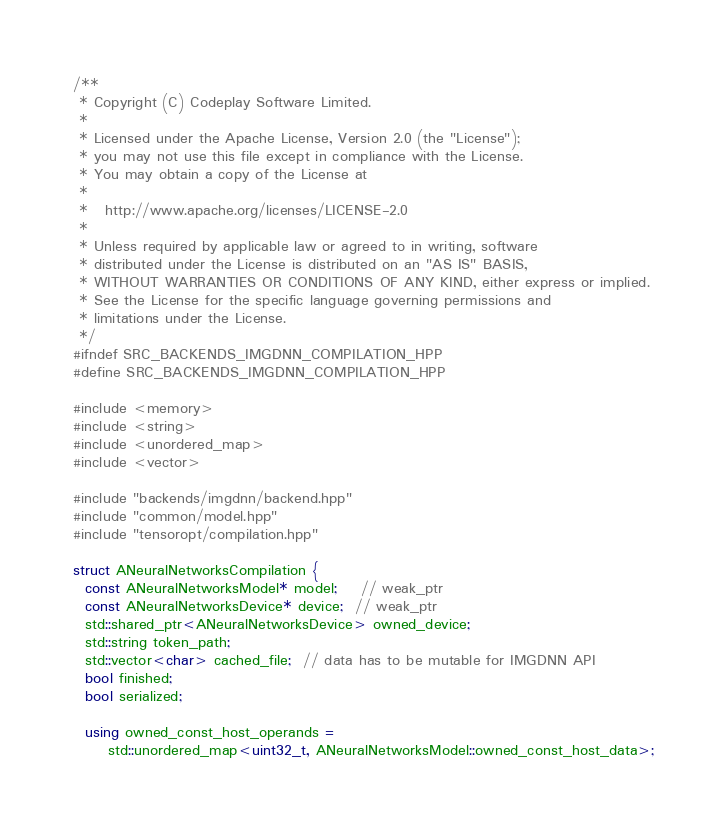<code> <loc_0><loc_0><loc_500><loc_500><_C++_>/**
 * Copyright (C) Codeplay Software Limited.
 *
 * Licensed under the Apache License, Version 2.0 (the "License");
 * you may not use this file except in compliance with the License.
 * You may obtain a copy of the License at
 *
 *   http://www.apache.org/licenses/LICENSE-2.0
 *
 * Unless required by applicable law or agreed to in writing, software
 * distributed under the License is distributed on an "AS IS" BASIS,
 * WITHOUT WARRANTIES OR CONDITIONS OF ANY KIND, either express or implied.
 * See the License for the specific language governing permissions and
 * limitations under the License.
 */
#ifndef SRC_BACKENDS_IMGDNN_COMPILATION_HPP
#define SRC_BACKENDS_IMGDNN_COMPILATION_HPP

#include <memory>
#include <string>
#include <unordered_map>
#include <vector>

#include "backends/imgdnn/backend.hpp"
#include "common/model.hpp"
#include "tensoropt/compilation.hpp"

struct ANeuralNetworksCompilation {
  const ANeuralNetworksModel* model;    // weak_ptr
  const ANeuralNetworksDevice* device;  // weak_ptr
  std::shared_ptr<ANeuralNetworksDevice> owned_device;
  std::string token_path;
  std::vector<char> cached_file;  // data has to be mutable for IMGDNN API
  bool finished;
  bool serialized;

  using owned_const_host_operands =
      std::unordered_map<uint32_t, ANeuralNetworksModel::owned_const_host_data>;
</code> 